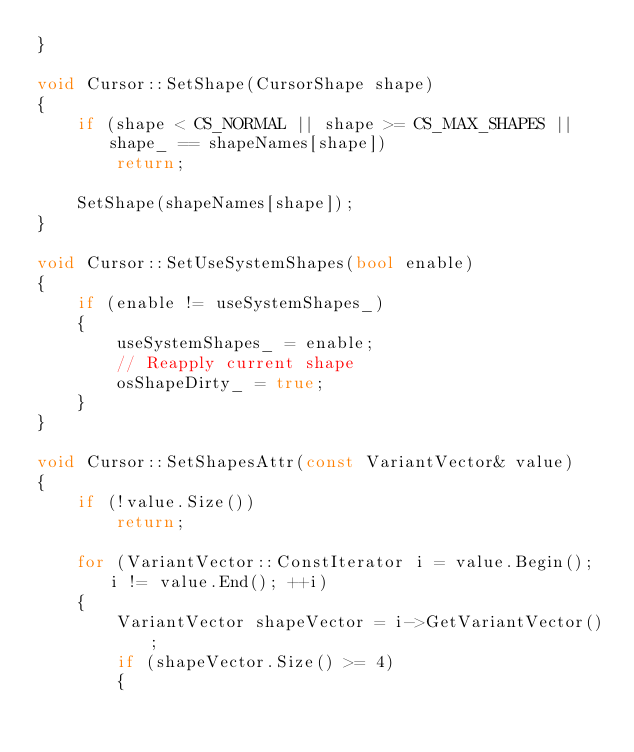Convert code to text. <code><loc_0><loc_0><loc_500><loc_500><_C++_>}

void Cursor::SetShape(CursorShape shape)
{
    if (shape < CS_NORMAL || shape >= CS_MAX_SHAPES || shape_ == shapeNames[shape])
        return;

    SetShape(shapeNames[shape]);
}

void Cursor::SetUseSystemShapes(bool enable)
{
    if (enable != useSystemShapes_)
    {
        useSystemShapes_ = enable;
        // Reapply current shape
        osShapeDirty_ = true;
    }
}

void Cursor::SetShapesAttr(const VariantVector& value)
{
    if (!value.Size())
        return;

    for (VariantVector::ConstIterator i = value.Begin(); i != value.End(); ++i)
    {
        VariantVector shapeVector = i->GetVariantVector();
        if (shapeVector.Size() >= 4)
        {</code> 